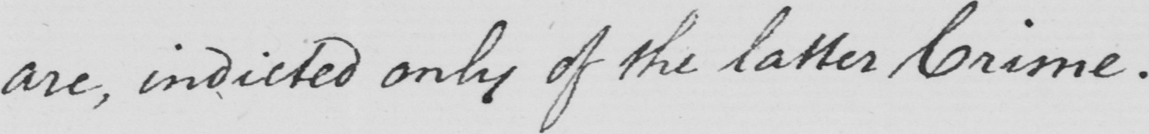Please provide the text content of this handwritten line. are , indicted only of the latter Crime . 